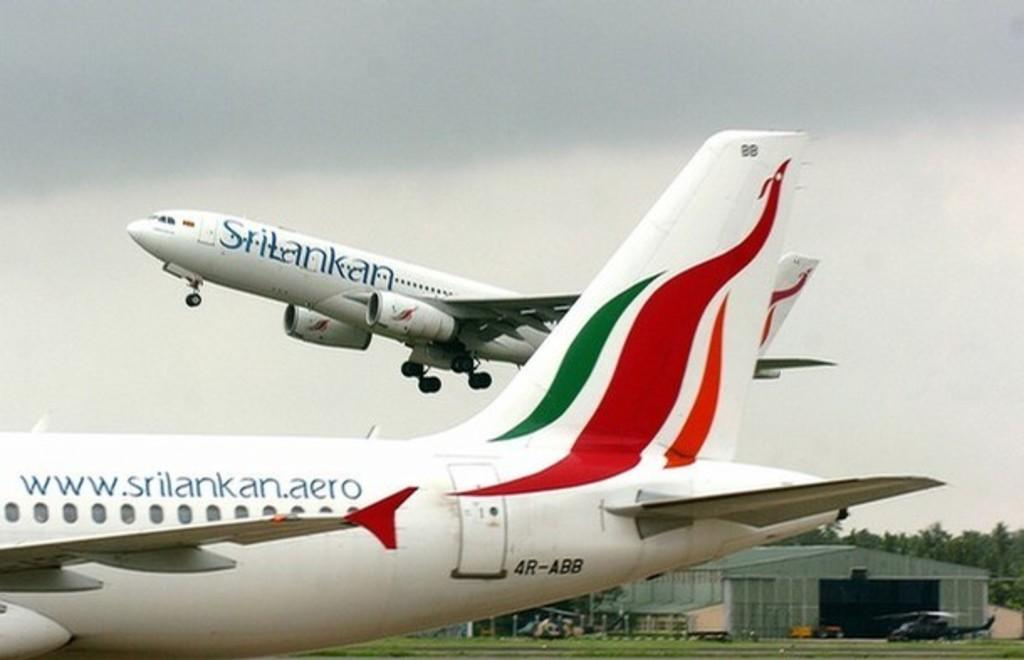<image>
Present a compact description of the photo's key features. A large commercial jet is taking off from the airport and says Srilankan on the side. 